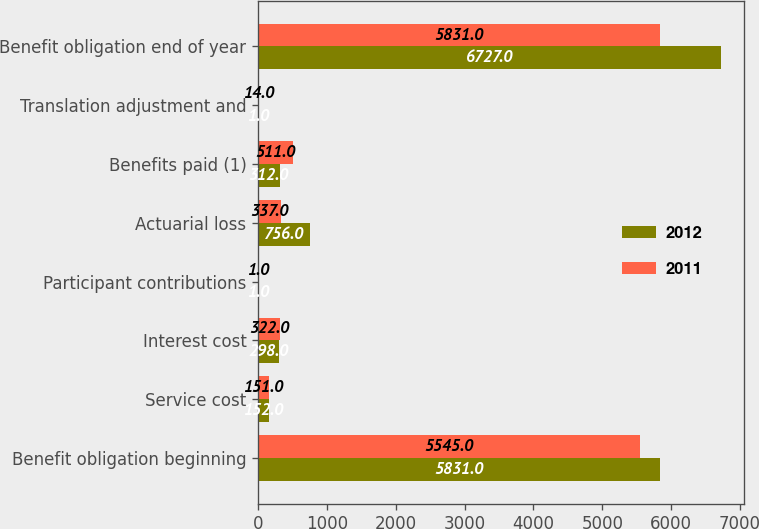<chart> <loc_0><loc_0><loc_500><loc_500><stacked_bar_chart><ecel><fcel>Benefit obligation beginning<fcel>Service cost<fcel>Interest cost<fcel>Participant contributions<fcel>Actuarial loss<fcel>Benefits paid (1)<fcel>Translation adjustment and<fcel>Benefit obligation end of year<nl><fcel>2012<fcel>5831<fcel>152<fcel>298<fcel>1<fcel>756<fcel>312<fcel>1<fcel>6727<nl><fcel>2011<fcel>5545<fcel>151<fcel>322<fcel>1<fcel>337<fcel>511<fcel>14<fcel>5831<nl></chart> 